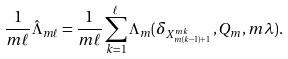<formula> <loc_0><loc_0><loc_500><loc_500>\frac { 1 } { m \ell } \hat { \Lambda } _ { m \ell } = \frac { 1 } { m \ell } \sum _ { k = 1 } ^ { \ell } \Lambda _ { m } ( \delta _ { X _ { m ( k - 1 ) + 1 } ^ { m k } } , Q _ { m } , m \lambda ) .</formula> 